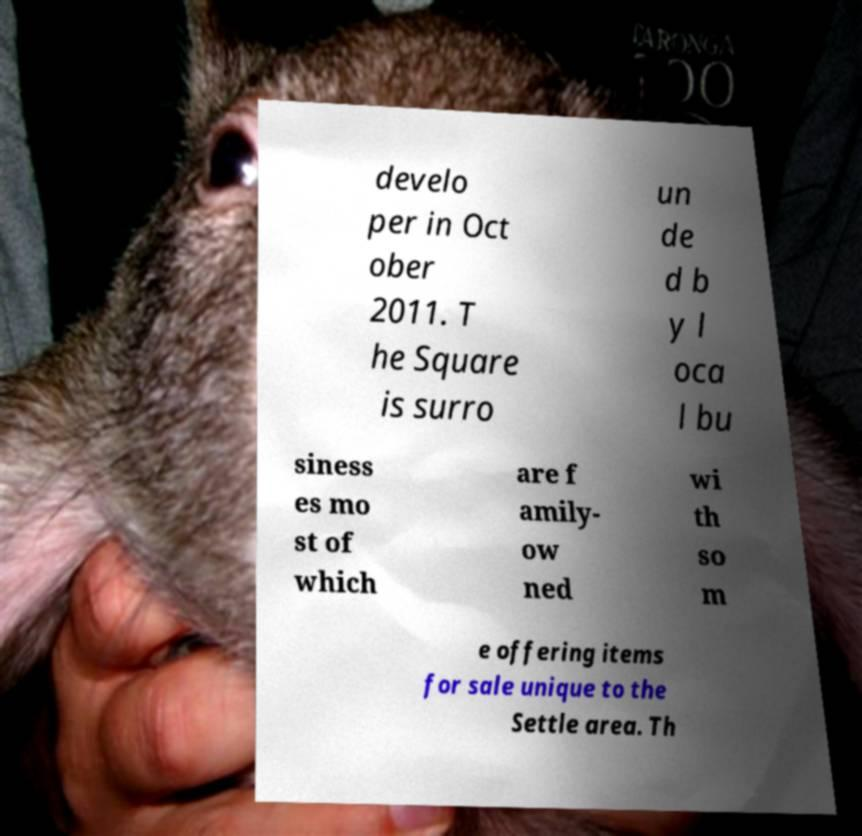Could you extract and type out the text from this image? develo per in Oct ober 2011. T he Square is surro un de d b y l oca l bu siness es mo st of which are f amily- ow ned wi th so m e offering items for sale unique to the Settle area. Th 